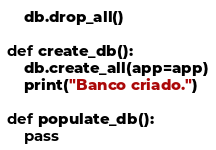<code> <loc_0><loc_0><loc_500><loc_500><_Python_>    db.drop_all()

def create_db():
    db.create_all(app=app)
    print("Banco criado.")

def populate_db():
    pass</code> 